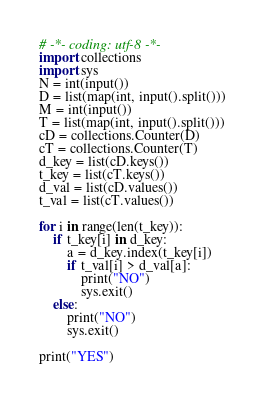<code> <loc_0><loc_0><loc_500><loc_500><_Python_># -*- coding: utf-8 -*-
import collections
import sys
N = int(input())
D = list(map(int, input().split()))
M = int(input())
T = list(map(int, input().split()))
cD = collections.Counter(D)
cT = collections.Counter(T)
d_key = list(cD.keys())
t_key = list(cT.keys())
d_val = list(cD.values())
t_val = list(cT.values())

for i in range(len(t_key)):
    if t_key[i] in d_key:
        a = d_key.index(t_key[i])
        if t_val[i] > d_val[a]:
            print("NO")
            sys.exit()
    else:
        print("NO")
        sys.exit()

print("YES")</code> 